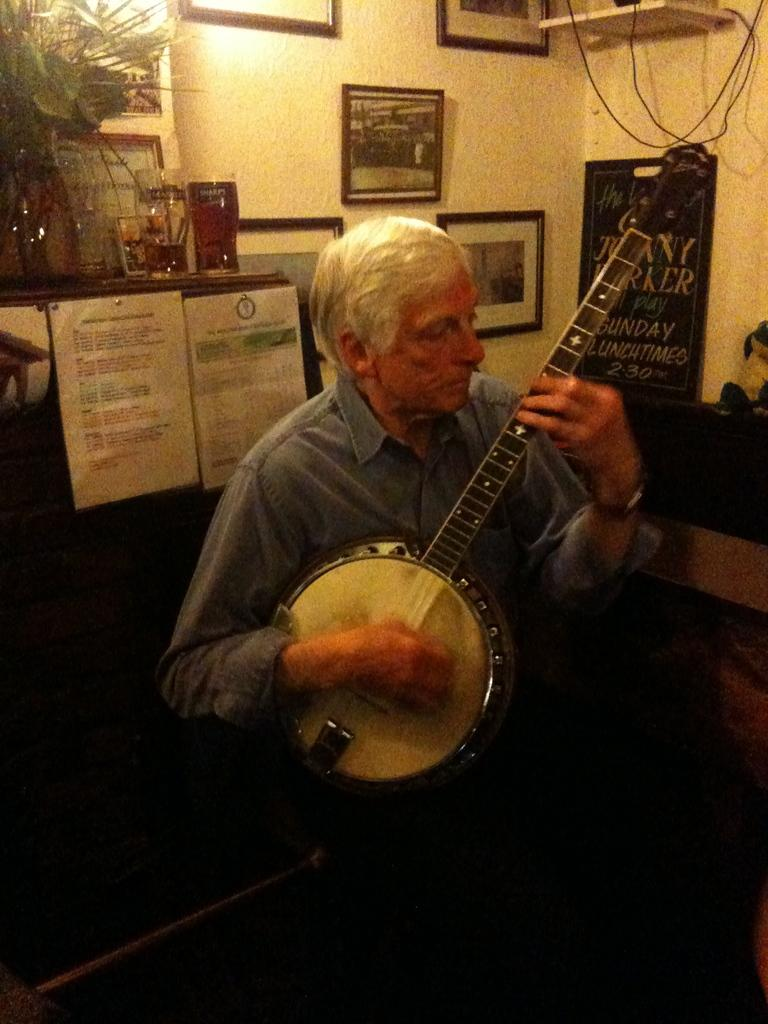Who is the main subject in the picture? There is an old man in the picture. What is the old man doing in the image? The old man is playing a musical instrument. What can be seen in the background of the image? There are two papers stuck on a board and a photo frame placed on the wall in the background. How many tramps are visible in the image? There are no tramps present in the image. Is there any exchange of goods or services happening in the image? There is no indication of any exchange of goods or services in the image. 